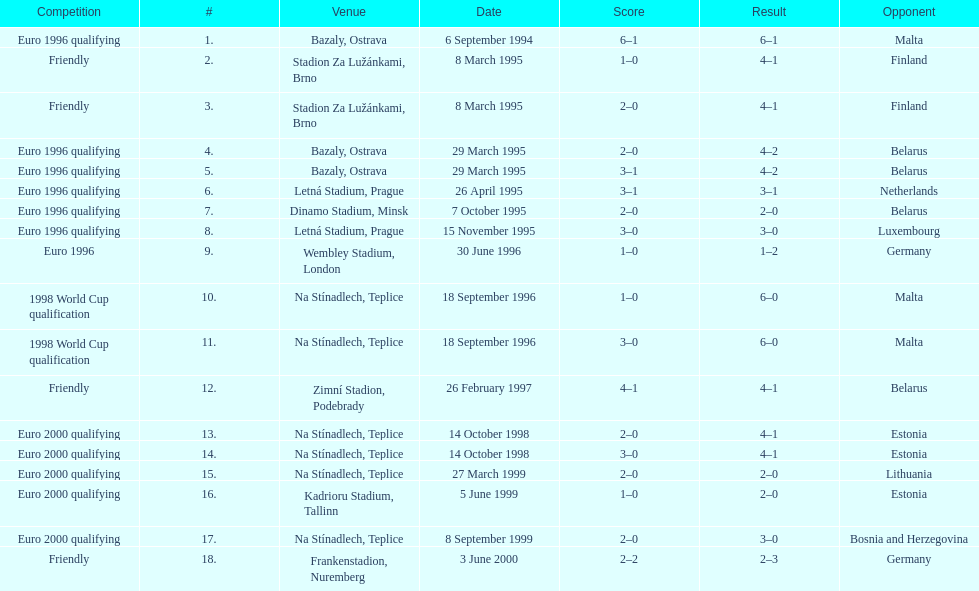How many total games took place in 1999? 3. 